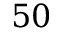<formula> <loc_0><loc_0><loc_500><loc_500>5 0</formula> 